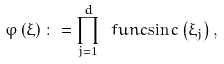Convert formula to latex. <formula><loc_0><loc_0><loc_500><loc_500>\varphi \left ( \xi \right ) \colon = \prod _ { j = 1 } ^ { d } \ f u n c { \sin c } \left ( \xi _ { j } \right ) ,</formula> 